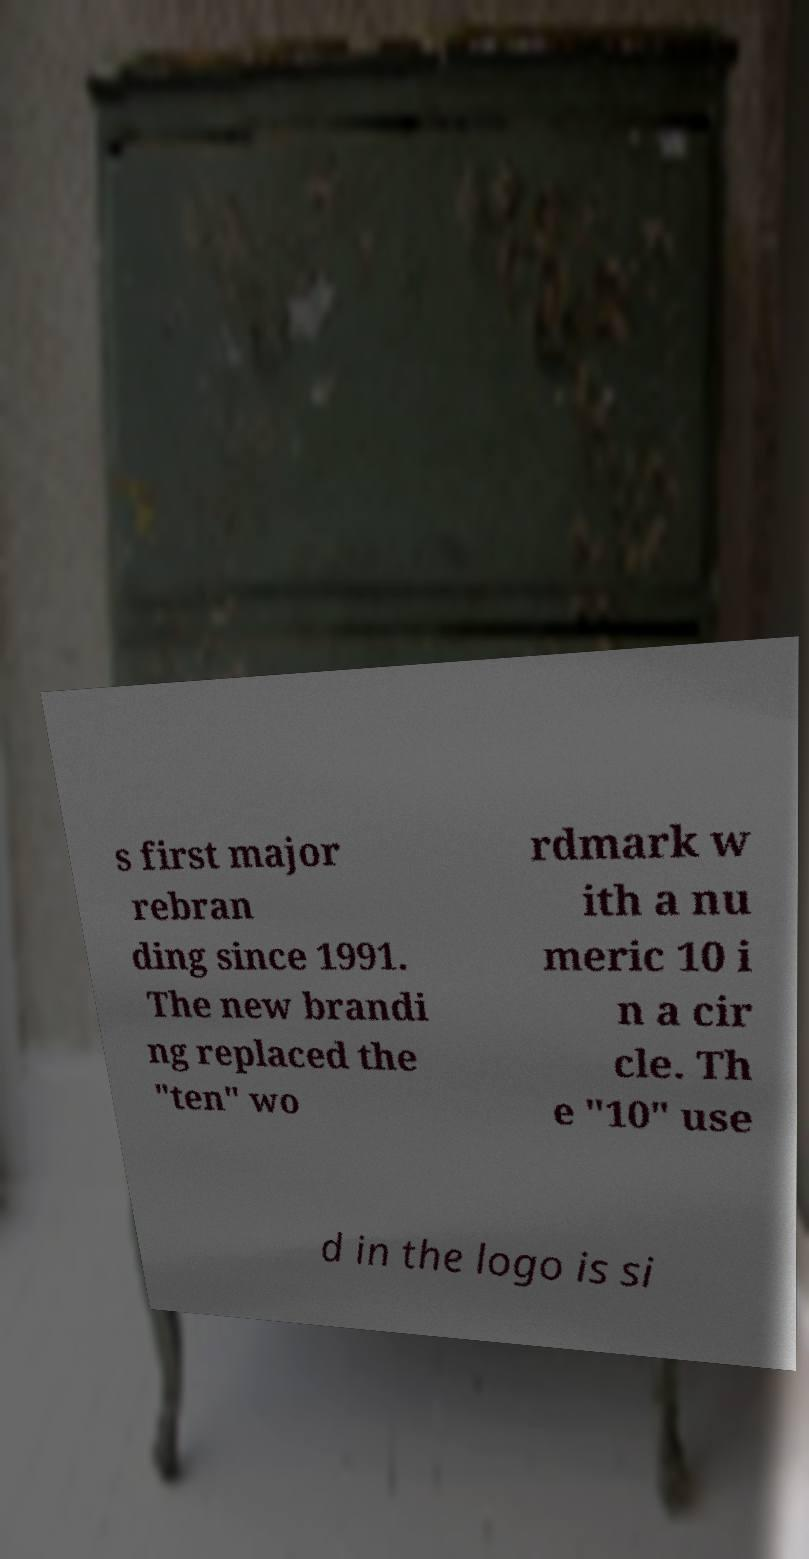I need the written content from this picture converted into text. Can you do that? s first major rebran ding since 1991. The new brandi ng replaced the "ten" wo rdmark w ith a nu meric 10 i n a cir cle. Th e "10" use d in the logo is si 